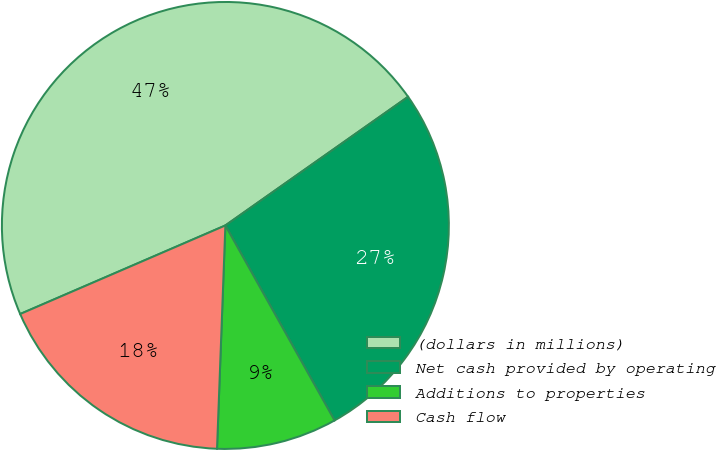Convert chart to OTSL. <chart><loc_0><loc_0><loc_500><loc_500><pie_chart><fcel>(dollars in millions)<fcel>Net cash provided by operating<fcel>Additions to properties<fcel>Cash flow<nl><fcel>46.72%<fcel>26.64%<fcel>8.72%<fcel>17.92%<nl></chart> 